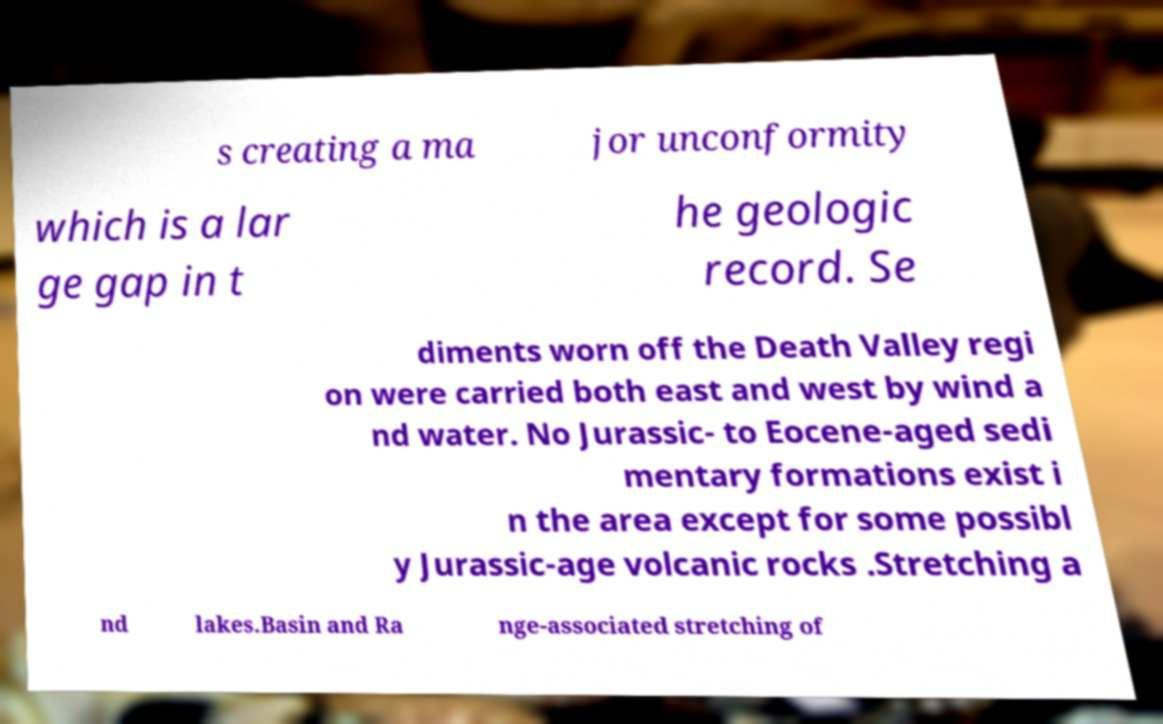There's text embedded in this image that I need extracted. Can you transcribe it verbatim? s creating a ma jor unconformity which is a lar ge gap in t he geologic record. Se diments worn off the Death Valley regi on were carried both east and west by wind a nd water. No Jurassic- to Eocene-aged sedi mentary formations exist i n the area except for some possibl y Jurassic-age volcanic rocks .Stretching a nd lakes.Basin and Ra nge-associated stretching of 